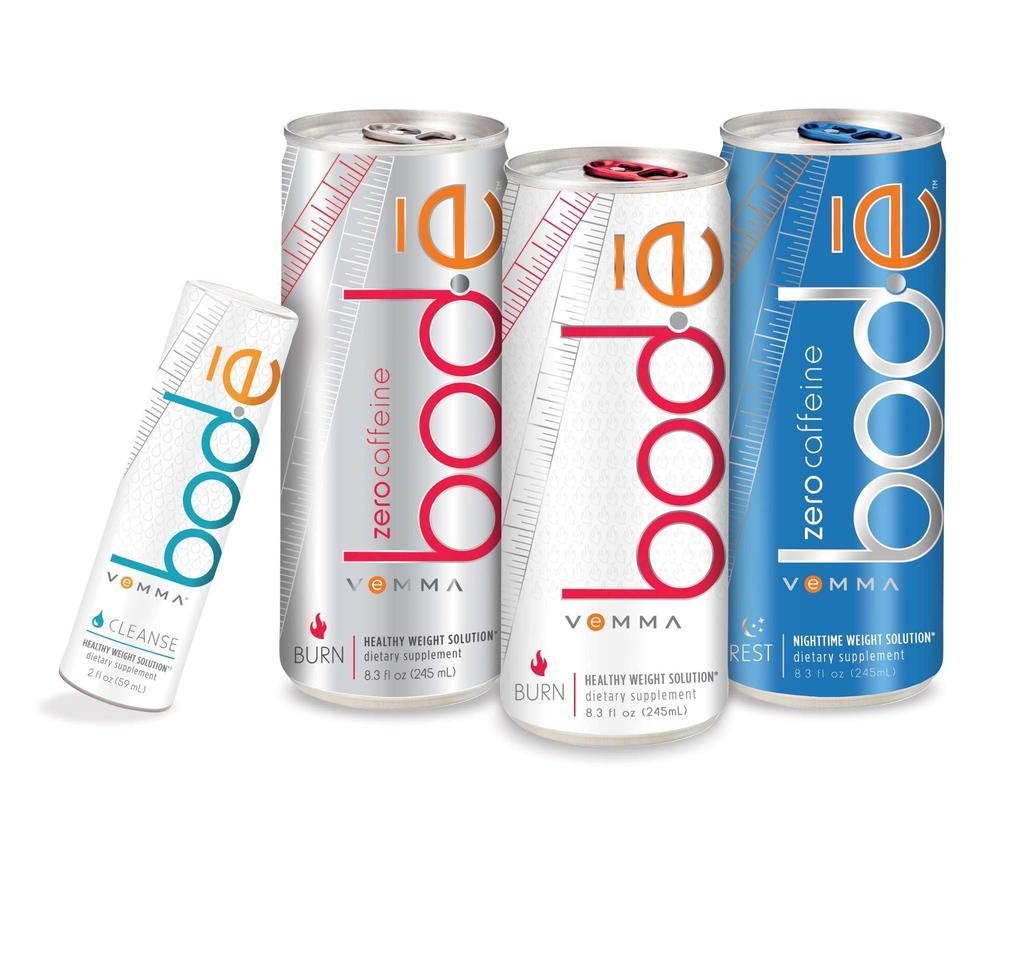<image>
Write a terse but informative summary of the picture. A image of four cans of Bode Zero Caffeine beverages. 